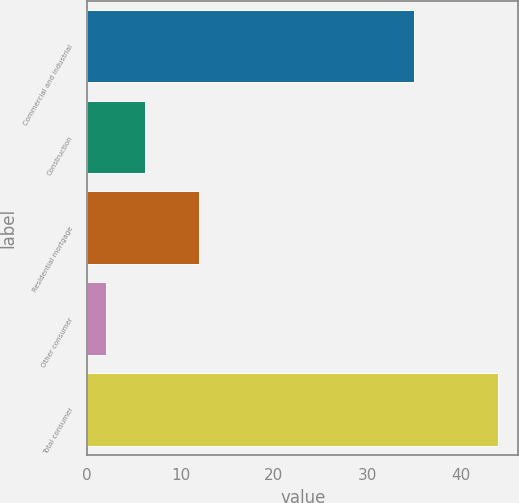Convert chart. <chart><loc_0><loc_0><loc_500><loc_500><bar_chart><fcel>Commercial and industrial<fcel>Construction<fcel>Residential mortgage<fcel>Other consumer<fcel>Total consumer<nl><fcel>35<fcel>6.2<fcel>12<fcel>2<fcel>44<nl></chart> 